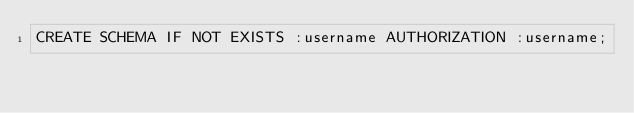<code> <loc_0><loc_0><loc_500><loc_500><_SQL_>CREATE SCHEMA IF NOT EXISTS :username AUTHORIZATION :username;
</code> 